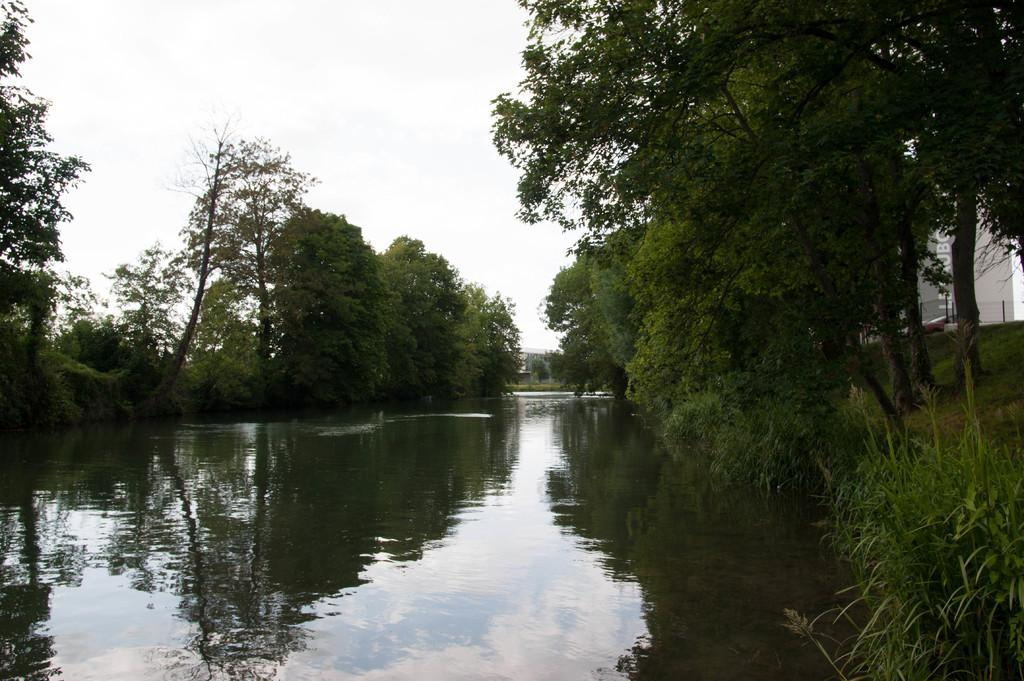What type of vegetation is on the right side of the image? There are plants and trees on the right side of the image. What structure is located on the right side of the image? There is a building on the right side of the image. What can be seen in the middle of the image? There is a canal in the middle of the image. What type of vegetation is on the left side of the image? There are trees on the left side of the image. What is visible at the top of the image? The sky is visible at the top of the image. Where is the beggar standing in the image? There is no beggar present in the image. What color is the kite flying in the sky in the image? There is no kite present in the sky in the image. 